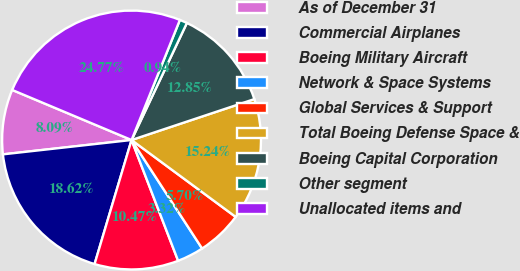Convert chart. <chart><loc_0><loc_0><loc_500><loc_500><pie_chart><fcel>As of December 31<fcel>Commercial Airplanes<fcel>Boeing Military Aircraft<fcel>Network & Space Systems<fcel>Global Services & Support<fcel>Total Boeing Defense Space &<fcel>Boeing Capital Corporation<fcel>Other segment<fcel>Unallocated items and<nl><fcel>8.09%<fcel>18.62%<fcel>10.47%<fcel>3.32%<fcel>5.7%<fcel>15.24%<fcel>12.85%<fcel>0.94%<fcel>24.77%<nl></chart> 